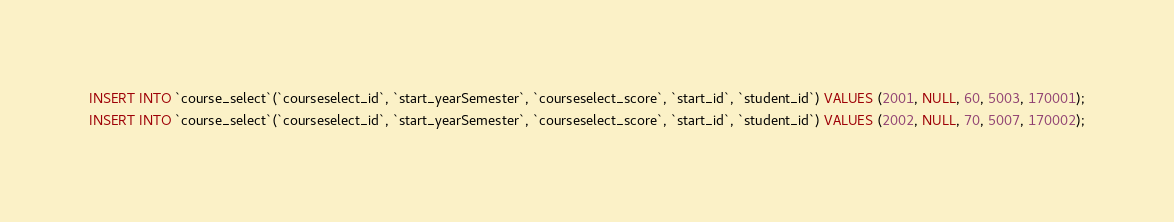<code> <loc_0><loc_0><loc_500><loc_500><_SQL_>INSERT INTO `course_select`(`courseselect_id`, `start_yearSemester`, `courseselect_score`, `start_id`, `student_id`) VALUES (2001, NULL, 60, 5003, 170001);
INSERT INTO `course_select`(`courseselect_id`, `start_yearSemester`, `courseselect_score`, `start_id`, `student_id`) VALUES (2002, NULL, 70, 5007, 170002);
</code> 